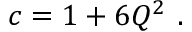Convert formula to latex. <formula><loc_0><loc_0><loc_500><loc_500>c = 1 + 6 Q ^ { 2 } \ .</formula> 